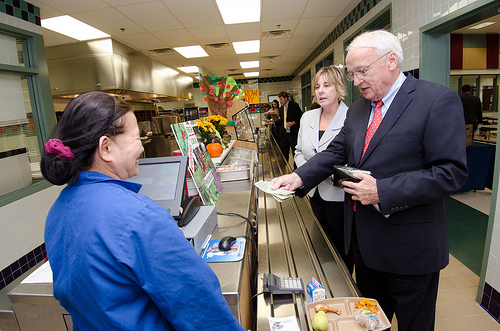<image>
Is there a man to the left of the woman? Yes. From this viewpoint, the man is positioned to the left side relative to the woman. 